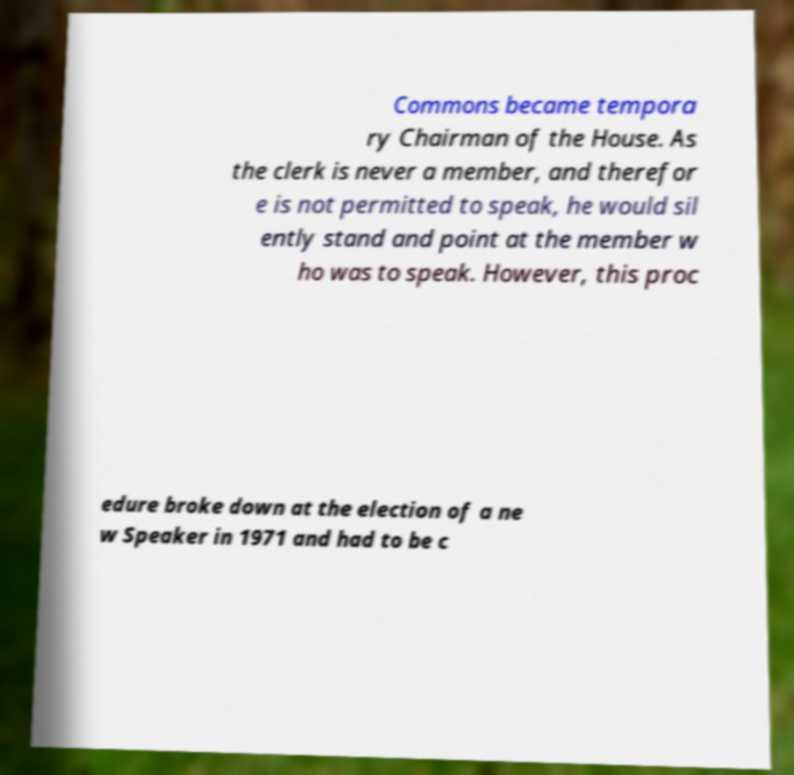What messages or text are displayed in this image? I need them in a readable, typed format. Commons became tempora ry Chairman of the House. As the clerk is never a member, and therefor e is not permitted to speak, he would sil ently stand and point at the member w ho was to speak. However, this proc edure broke down at the election of a ne w Speaker in 1971 and had to be c 